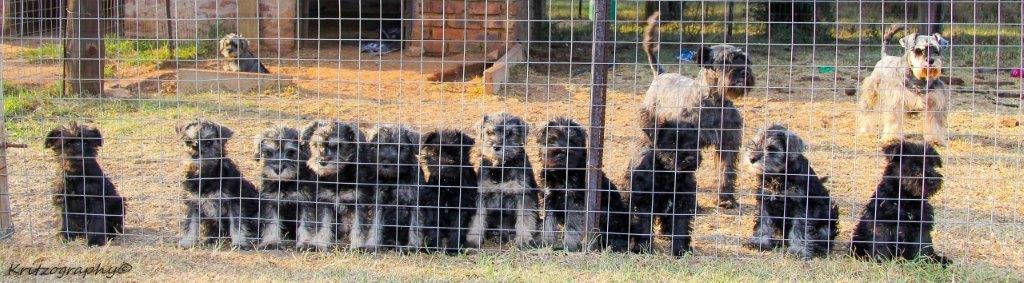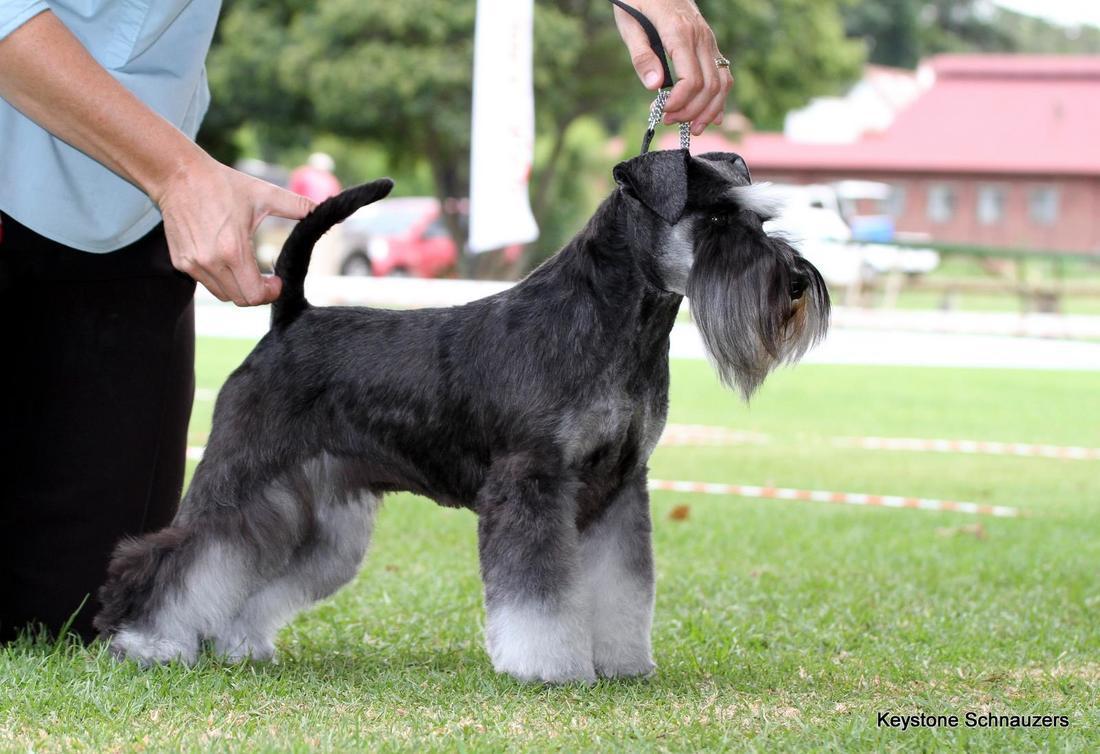The first image is the image on the left, the second image is the image on the right. Analyze the images presented: Is the assertion "At least 4 dogs are standing behind a fence looking out." valid? Answer yes or no. Yes. The first image is the image on the left, the second image is the image on the right. Evaluate the accuracy of this statement regarding the images: "there are no more than 4 dogs behind a wire fence in the image pair". Is it true? Answer yes or no. No. 